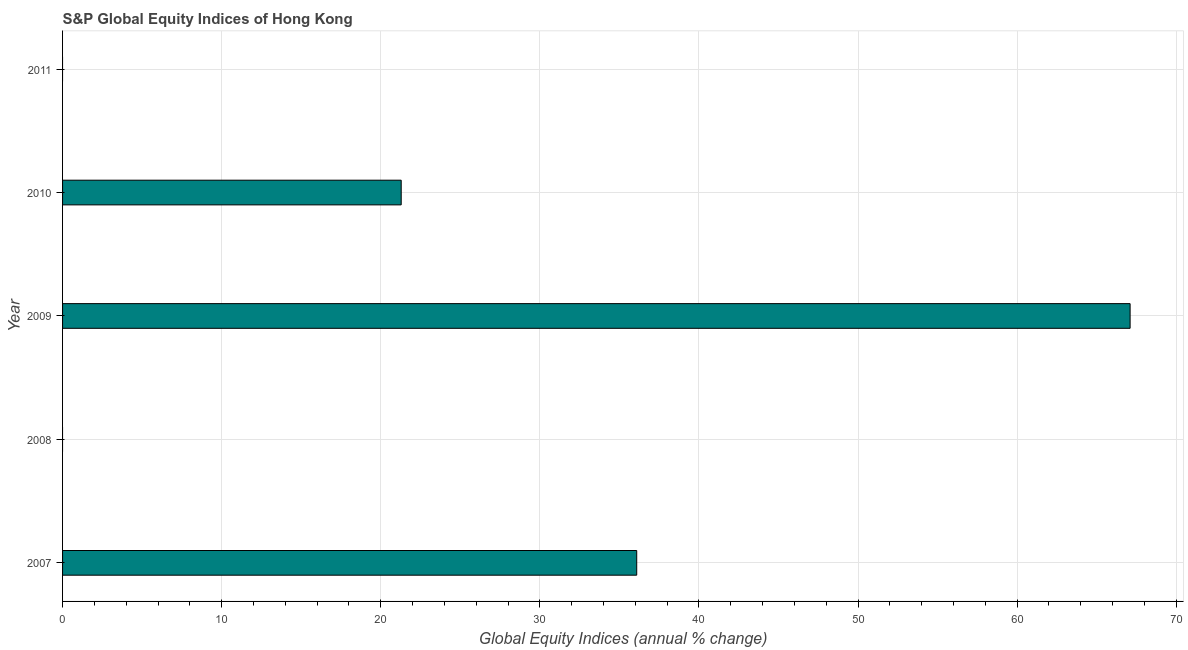Does the graph contain any zero values?
Provide a succinct answer. Yes. What is the title of the graph?
Keep it short and to the point. S&P Global Equity Indices of Hong Kong. What is the label or title of the X-axis?
Your answer should be compact. Global Equity Indices (annual % change). Across all years, what is the maximum s&p global equity indices?
Offer a very short reply. 67.1. In which year was the s&p global equity indices maximum?
Ensure brevity in your answer.  2009. What is the sum of the s&p global equity indices?
Offer a terse response. 124.48. What is the difference between the s&p global equity indices in 2007 and 2009?
Make the answer very short. -31.01. What is the average s&p global equity indices per year?
Ensure brevity in your answer.  24.9. What is the median s&p global equity indices?
Your response must be concise. 21.29. In how many years, is the s&p global equity indices greater than 62 %?
Your response must be concise. 1. What is the difference between the highest and the second highest s&p global equity indices?
Keep it short and to the point. 31.01. Is the sum of the s&p global equity indices in 2007 and 2010 greater than the maximum s&p global equity indices across all years?
Provide a succinct answer. No. What is the difference between the highest and the lowest s&p global equity indices?
Make the answer very short. 67.1. Are all the bars in the graph horizontal?
Offer a terse response. Yes. What is the difference between two consecutive major ticks on the X-axis?
Offer a very short reply. 10. Are the values on the major ticks of X-axis written in scientific E-notation?
Offer a very short reply. No. What is the Global Equity Indices (annual % change) in 2007?
Provide a succinct answer. 36.09. What is the Global Equity Indices (annual % change) in 2008?
Keep it short and to the point. 0. What is the Global Equity Indices (annual % change) in 2009?
Offer a very short reply. 67.1. What is the Global Equity Indices (annual % change) of 2010?
Provide a short and direct response. 21.29. What is the difference between the Global Equity Indices (annual % change) in 2007 and 2009?
Your answer should be compact. -31.01. What is the difference between the Global Equity Indices (annual % change) in 2007 and 2010?
Offer a very short reply. 14.8. What is the difference between the Global Equity Indices (annual % change) in 2009 and 2010?
Make the answer very short. 45.82. What is the ratio of the Global Equity Indices (annual % change) in 2007 to that in 2009?
Make the answer very short. 0.54. What is the ratio of the Global Equity Indices (annual % change) in 2007 to that in 2010?
Ensure brevity in your answer.  1.7. What is the ratio of the Global Equity Indices (annual % change) in 2009 to that in 2010?
Ensure brevity in your answer.  3.15. 